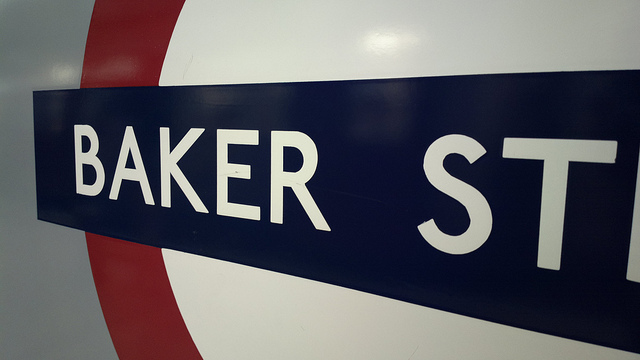Identify and read out the text in this image. BAKER ST 